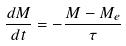<formula> <loc_0><loc_0><loc_500><loc_500>\frac { d M } { d t } = - \frac { M - M _ { e } } { \tau }</formula> 